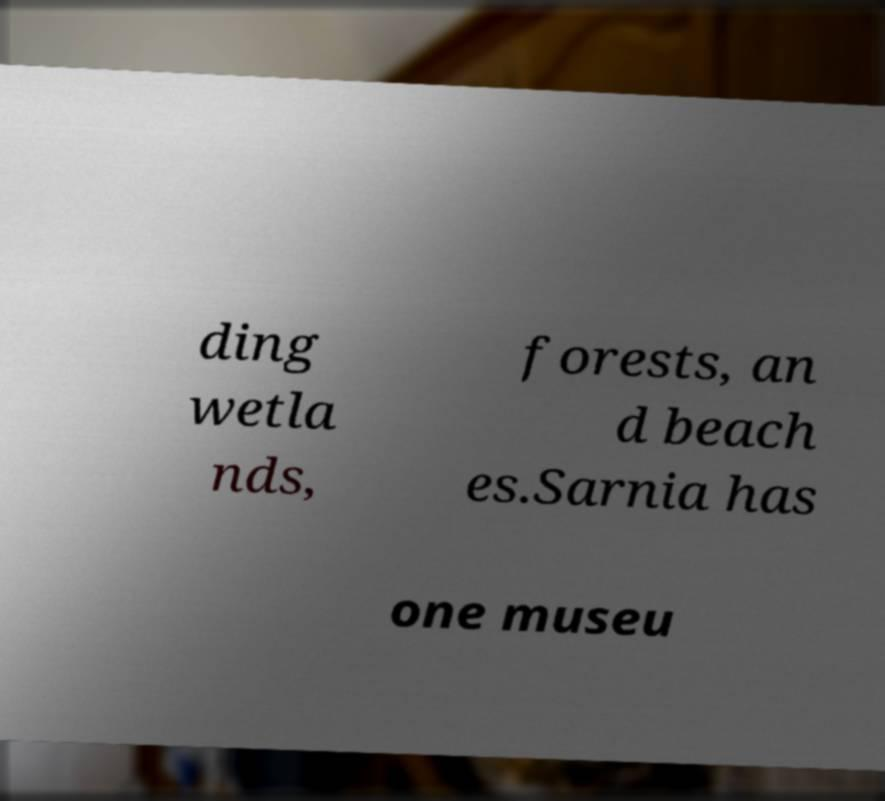Could you extract and type out the text from this image? ding wetla nds, forests, an d beach es.Sarnia has one museu 